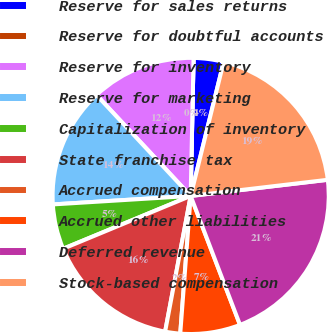Convert chart to OTSL. <chart><loc_0><loc_0><loc_500><loc_500><pie_chart><fcel>Reserve for sales returns<fcel>Reserve for doubtful accounts<fcel>Reserve for inventory<fcel>Reserve for marketing<fcel>Capitalization of inventory<fcel>State franchise tax<fcel>Accrued compensation<fcel>Accrued other liabilities<fcel>Deferred revenue<fcel>Stock-based compensation<nl><fcel>3.51%<fcel>0.0%<fcel>12.28%<fcel>14.03%<fcel>5.27%<fcel>15.79%<fcel>1.76%<fcel>7.02%<fcel>21.05%<fcel>19.29%<nl></chart> 